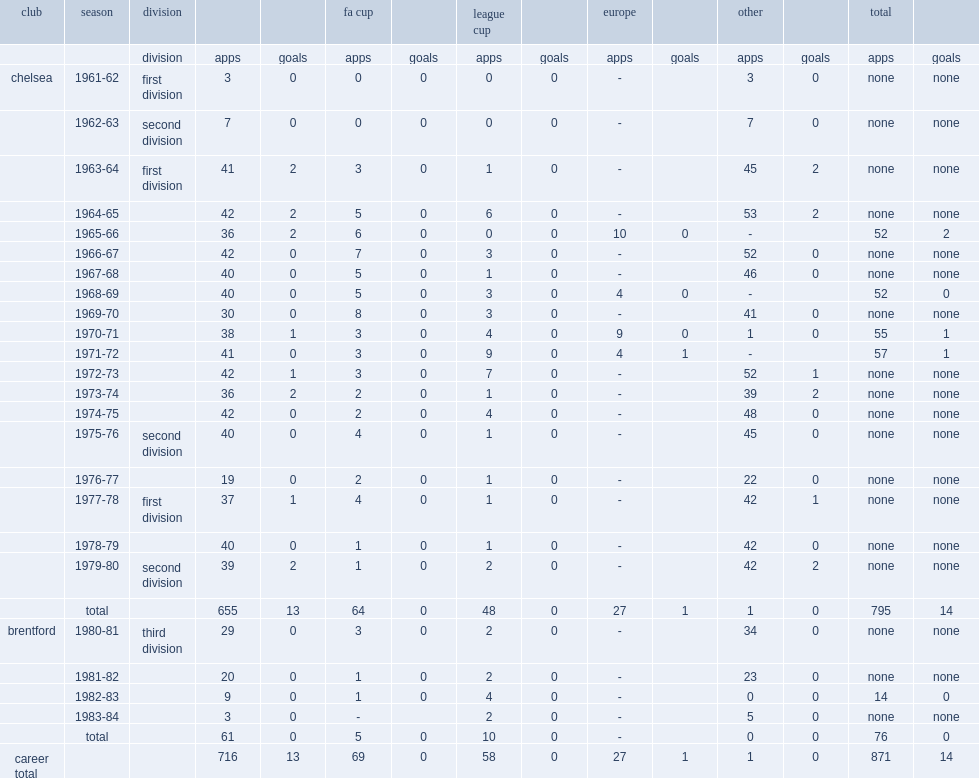How many games did ron harris play for chelsea? 795.0. 